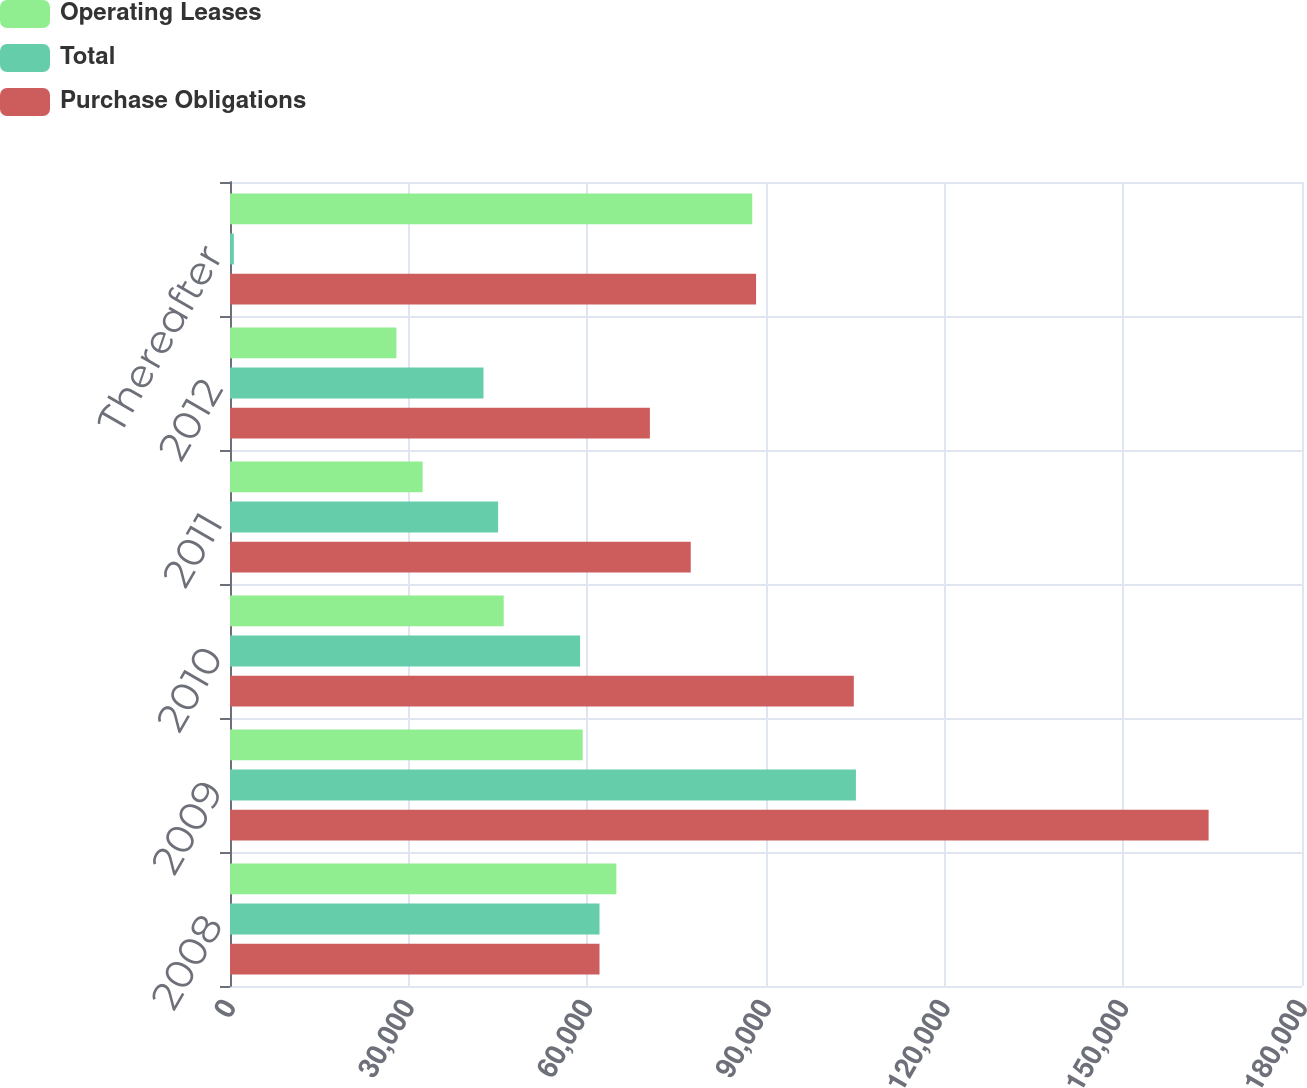Convert chart to OTSL. <chart><loc_0><loc_0><loc_500><loc_500><stacked_bar_chart><ecel><fcel>2008<fcel>2009<fcel>2010<fcel>2011<fcel>2012<fcel>Thereafter<nl><fcel>Operating Leases<fcel>64870<fcel>59221<fcel>45960<fcel>32342<fcel>27940<fcel>87688<nl><fcel>Total<fcel>62045.5<fcel>105099<fcel>58786<fcel>45019<fcel>42563<fcel>643<nl><fcel>Purchase Obligations<fcel>62045.5<fcel>164320<fcel>104746<fcel>77361<fcel>70503<fcel>88331<nl></chart> 